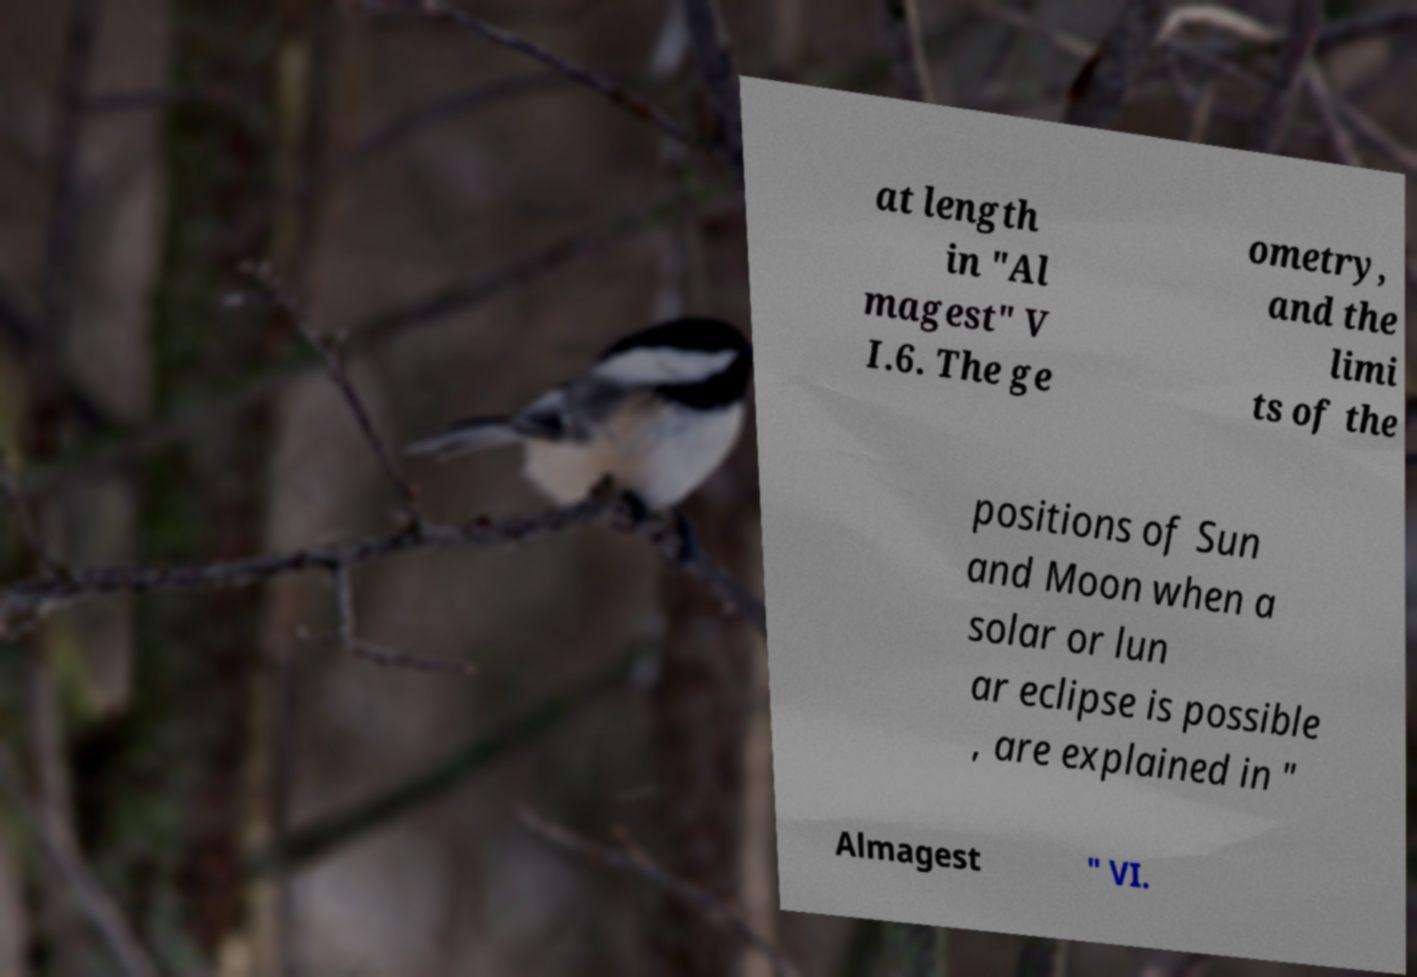Could you extract and type out the text from this image? at length in "Al magest" V I.6. The ge ometry, and the limi ts of the positions of Sun and Moon when a solar or lun ar eclipse is possible , are explained in " Almagest " VI. 